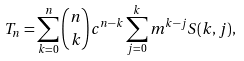<formula> <loc_0><loc_0><loc_500><loc_500>T _ { n } = \sum _ { k = 0 } ^ { n } { n \choose k } c ^ { n - k } \sum _ { j = 0 } ^ { k } m ^ { k - j } S ( k , j ) ,</formula> 